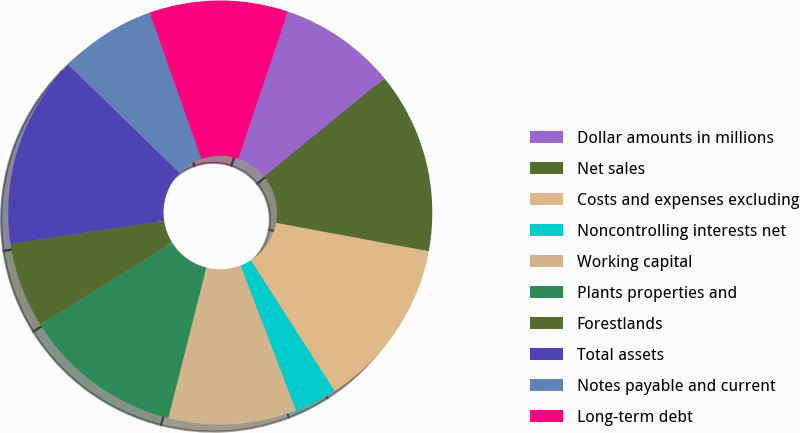<chart> <loc_0><loc_0><loc_500><loc_500><pie_chart><fcel>Dollar amounts in millions<fcel>Net sales<fcel>Costs and expenses excluding<fcel>Noncontrolling interests net<fcel>Working capital<fcel>Plants properties and<fcel>Forestlands<fcel>Total assets<fcel>Notes payable and current<fcel>Long-term debt<nl><fcel>8.94%<fcel>13.82%<fcel>13.01%<fcel>3.25%<fcel>9.76%<fcel>12.2%<fcel>6.5%<fcel>14.63%<fcel>7.32%<fcel>10.57%<nl></chart> 